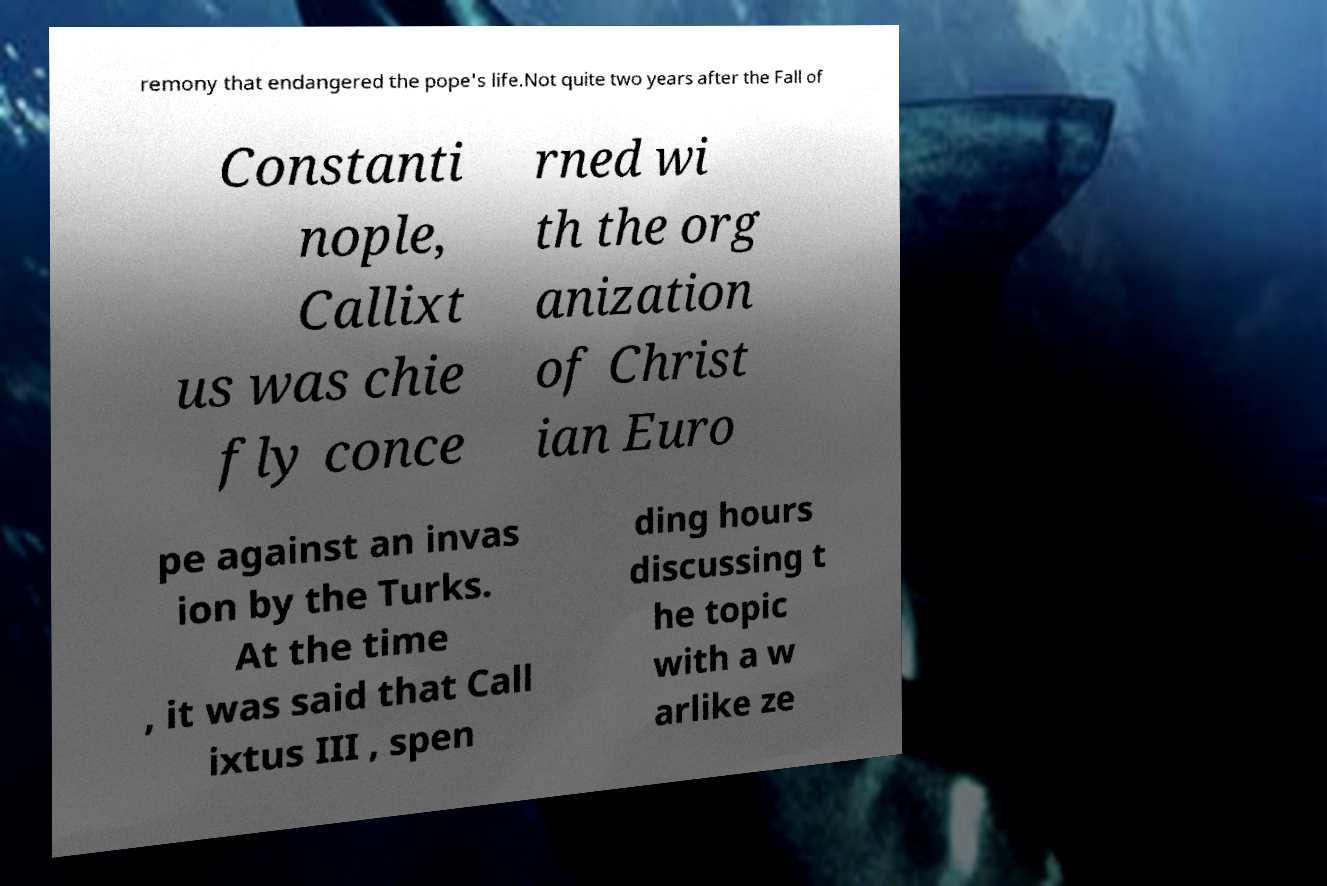Could you extract and type out the text from this image? remony that endangered the pope's life.Not quite two years after the Fall of Constanti nople, Callixt us was chie fly conce rned wi th the org anization of Christ ian Euro pe against an invas ion by the Turks. At the time , it was said that Call ixtus III , spen ding hours discussing t he topic with a w arlike ze 